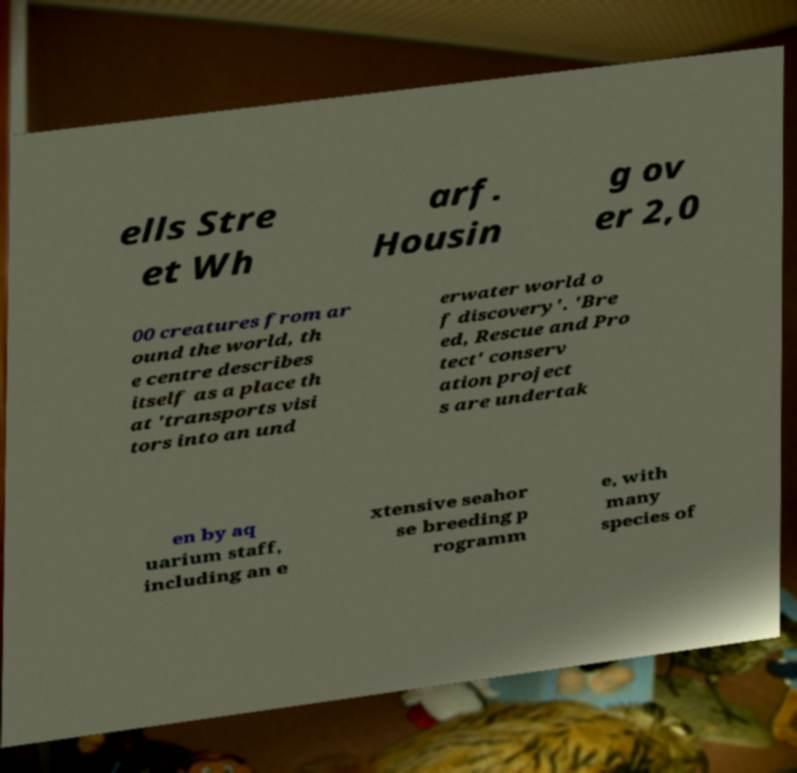For documentation purposes, I need the text within this image transcribed. Could you provide that? ells Stre et Wh arf. Housin g ov er 2,0 00 creatures from ar ound the world, th e centre describes itself as a place th at 'transports visi tors into an und erwater world o f discovery'. 'Bre ed, Rescue and Pro tect' conserv ation project s are undertak en by aq uarium staff, including an e xtensive seahor se breeding p rogramm e, with many species of 